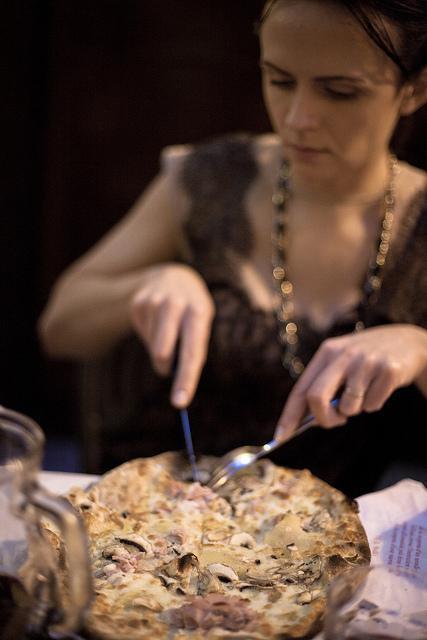Is the given caption "The pizza is touching the person." fitting for the image?
Answer yes or no. No. 